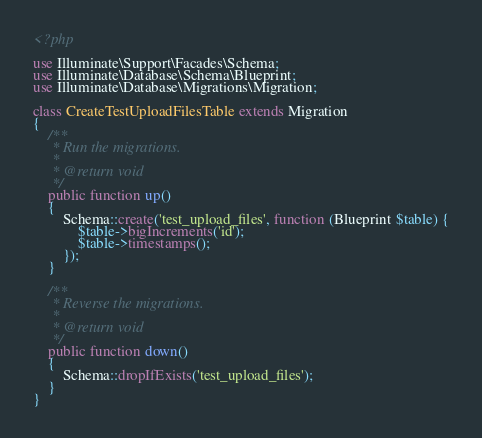Convert code to text. <code><loc_0><loc_0><loc_500><loc_500><_PHP_><?php

use Illuminate\Support\Facades\Schema;
use Illuminate\Database\Schema\Blueprint;
use Illuminate\Database\Migrations\Migration;

class CreateTestUploadFilesTable extends Migration
{
    /**
     * Run the migrations.
     *
     * @return void
     */
    public function up()
    {
        Schema::create('test_upload_files', function (Blueprint $table) {
            $table->bigIncrements('id');
            $table->timestamps();
        });
    }

    /**
     * Reverse the migrations.
     *
     * @return void
     */
    public function down()
    {
        Schema::dropIfExists('test_upload_files');
    }
}
</code> 